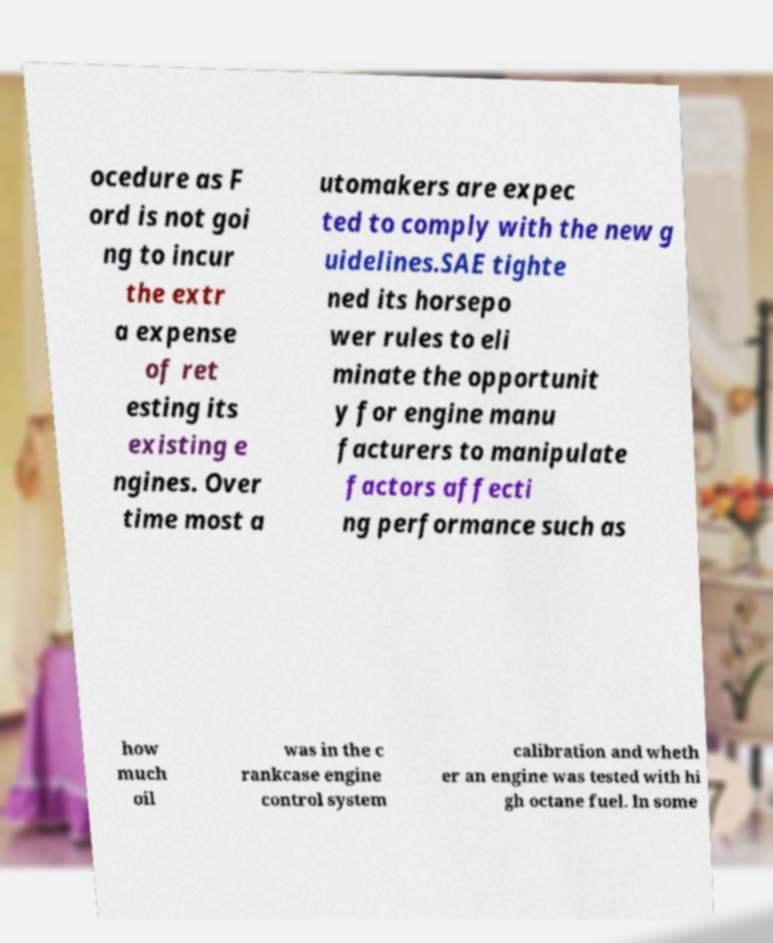Could you extract and type out the text from this image? ocedure as F ord is not goi ng to incur the extr a expense of ret esting its existing e ngines. Over time most a utomakers are expec ted to comply with the new g uidelines.SAE tighte ned its horsepo wer rules to eli minate the opportunit y for engine manu facturers to manipulate factors affecti ng performance such as how much oil was in the c rankcase engine control system calibration and wheth er an engine was tested with hi gh octane fuel. In some 